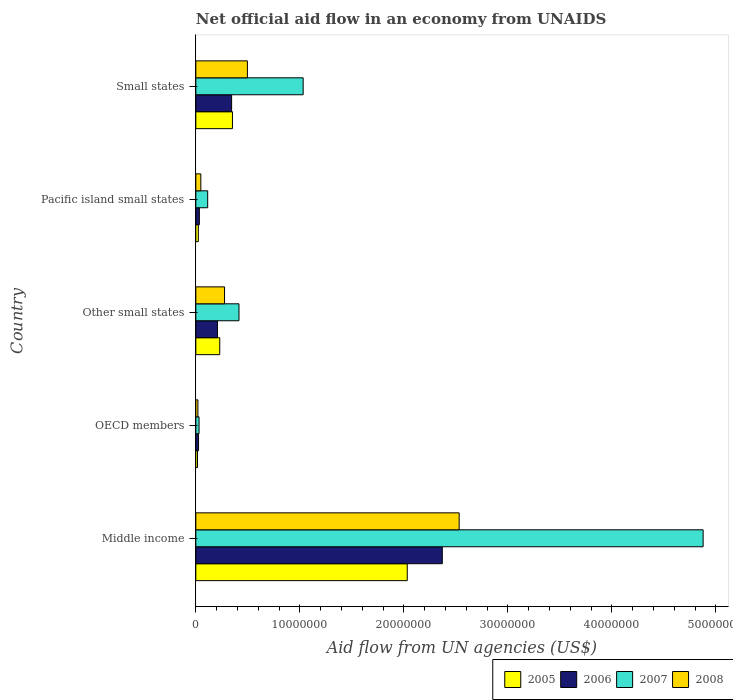How many groups of bars are there?
Ensure brevity in your answer.  5. Are the number of bars on each tick of the Y-axis equal?
Keep it short and to the point. Yes. How many bars are there on the 3rd tick from the top?
Provide a succinct answer. 4. What is the label of the 5th group of bars from the top?
Make the answer very short. Middle income. What is the net official aid flow in 2008 in Other small states?
Your answer should be compact. 2.76e+06. Across all countries, what is the maximum net official aid flow in 2005?
Offer a terse response. 2.03e+07. Across all countries, what is the minimum net official aid flow in 2007?
Your response must be concise. 3.10e+05. In which country was the net official aid flow in 2006 maximum?
Make the answer very short. Middle income. In which country was the net official aid flow in 2007 minimum?
Provide a succinct answer. OECD members. What is the total net official aid flow in 2005 in the graph?
Keep it short and to the point. 2.66e+07. What is the difference between the net official aid flow in 2005 in Pacific island small states and that in Small states?
Your response must be concise. -3.28e+06. What is the difference between the net official aid flow in 2007 in Other small states and the net official aid flow in 2006 in Middle income?
Provide a succinct answer. -1.96e+07. What is the average net official aid flow in 2006 per country?
Provide a short and direct response. 5.96e+06. What is the difference between the net official aid flow in 2005 and net official aid flow in 2008 in Small states?
Provide a succinct answer. -1.44e+06. In how many countries, is the net official aid flow in 2007 greater than 12000000 US$?
Your answer should be compact. 1. What is the ratio of the net official aid flow in 2005 in Pacific island small states to that in Small states?
Provide a succinct answer. 0.07. Is the difference between the net official aid flow in 2005 in Middle income and Small states greater than the difference between the net official aid flow in 2008 in Middle income and Small states?
Make the answer very short. No. What is the difference between the highest and the second highest net official aid flow in 2008?
Keep it short and to the point. 2.04e+07. What is the difference between the highest and the lowest net official aid flow in 2006?
Your answer should be compact. 2.34e+07. In how many countries, is the net official aid flow in 2006 greater than the average net official aid flow in 2006 taken over all countries?
Your response must be concise. 1. Is it the case that in every country, the sum of the net official aid flow in 2007 and net official aid flow in 2008 is greater than the sum of net official aid flow in 2005 and net official aid flow in 2006?
Ensure brevity in your answer.  No. What does the 4th bar from the top in Pacific island small states represents?
Offer a terse response. 2005. Is it the case that in every country, the sum of the net official aid flow in 2005 and net official aid flow in 2006 is greater than the net official aid flow in 2007?
Give a very brief answer. No. How many bars are there?
Your answer should be compact. 20. How many countries are there in the graph?
Provide a short and direct response. 5. What is the difference between two consecutive major ticks on the X-axis?
Your answer should be compact. 1.00e+07. Does the graph contain any zero values?
Offer a terse response. No. Does the graph contain grids?
Ensure brevity in your answer.  No. Where does the legend appear in the graph?
Your answer should be compact. Bottom right. What is the title of the graph?
Keep it short and to the point. Net official aid flow in an economy from UNAIDS. Does "2002" appear as one of the legend labels in the graph?
Offer a very short reply. No. What is the label or title of the X-axis?
Provide a succinct answer. Aid flow from UN agencies (US$). What is the Aid flow from UN agencies (US$) in 2005 in Middle income?
Your answer should be very brief. 2.03e+07. What is the Aid flow from UN agencies (US$) in 2006 in Middle income?
Offer a very short reply. 2.37e+07. What is the Aid flow from UN agencies (US$) of 2007 in Middle income?
Offer a terse response. 4.88e+07. What is the Aid flow from UN agencies (US$) of 2008 in Middle income?
Make the answer very short. 2.53e+07. What is the Aid flow from UN agencies (US$) of 2005 in OECD members?
Keep it short and to the point. 1.60e+05. What is the Aid flow from UN agencies (US$) of 2007 in OECD members?
Your answer should be compact. 3.10e+05. What is the Aid flow from UN agencies (US$) in 2005 in Other small states?
Offer a terse response. 2.30e+06. What is the Aid flow from UN agencies (US$) of 2006 in Other small states?
Provide a short and direct response. 2.08e+06. What is the Aid flow from UN agencies (US$) in 2007 in Other small states?
Your response must be concise. 4.15e+06. What is the Aid flow from UN agencies (US$) in 2008 in Other small states?
Keep it short and to the point. 2.76e+06. What is the Aid flow from UN agencies (US$) in 2005 in Pacific island small states?
Your response must be concise. 2.40e+05. What is the Aid flow from UN agencies (US$) in 2006 in Pacific island small states?
Provide a succinct answer. 3.40e+05. What is the Aid flow from UN agencies (US$) in 2007 in Pacific island small states?
Ensure brevity in your answer.  1.14e+06. What is the Aid flow from UN agencies (US$) of 2005 in Small states?
Make the answer very short. 3.52e+06. What is the Aid flow from UN agencies (US$) of 2006 in Small states?
Offer a terse response. 3.44e+06. What is the Aid flow from UN agencies (US$) in 2007 in Small states?
Provide a succinct answer. 1.03e+07. What is the Aid flow from UN agencies (US$) of 2008 in Small states?
Ensure brevity in your answer.  4.96e+06. Across all countries, what is the maximum Aid flow from UN agencies (US$) of 2005?
Keep it short and to the point. 2.03e+07. Across all countries, what is the maximum Aid flow from UN agencies (US$) in 2006?
Keep it short and to the point. 2.37e+07. Across all countries, what is the maximum Aid flow from UN agencies (US$) in 2007?
Provide a succinct answer. 4.88e+07. Across all countries, what is the maximum Aid flow from UN agencies (US$) in 2008?
Offer a terse response. 2.53e+07. Across all countries, what is the minimum Aid flow from UN agencies (US$) in 2006?
Ensure brevity in your answer.  2.60e+05. Across all countries, what is the minimum Aid flow from UN agencies (US$) of 2008?
Your answer should be compact. 2.00e+05. What is the total Aid flow from UN agencies (US$) in 2005 in the graph?
Your answer should be very brief. 2.66e+07. What is the total Aid flow from UN agencies (US$) in 2006 in the graph?
Keep it short and to the point. 2.98e+07. What is the total Aid flow from UN agencies (US$) of 2007 in the graph?
Give a very brief answer. 6.47e+07. What is the total Aid flow from UN agencies (US$) in 2008 in the graph?
Your answer should be very brief. 3.37e+07. What is the difference between the Aid flow from UN agencies (US$) in 2005 in Middle income and that in OECD members?
Offer a terse response. 2.02e+07. What is the difference between the Aid flow from UN agencies (US$) in 2006 in Middle income and that in OECD members?
Your response must be concise. 2.34e+07. What is the difference between the Aid flow from UN agencies (US$) in 2007 in Middle income and that in OECD members?
Offer a terse response. 4.85e+07. What is the difference between the Aid flow from UN agencies (US$) of 2008 in Middle income and that in OECD members?
Your response must be concise. 2.51e+07. What is the difference between the Aid flow from UN agencies (US$) in 2005 in Middle income and that in Other small states?
Keep it short and to the point. 1.80e+07. What is the difference between the Aid flow from UN agencies (US$) in 2006 in Middle income and that in Other small states?
Keep it short and to the point. 2.16e+07. What is the difference between the Aid flow from UN agencies (US$) in 2007 in Middle income and that in Other small states?
Your response must be concise. 4.46e+07. What is the difference between the Aid flow from UN agencies (US$) of 2008 in Middle income and that in Other small states?
Keep it short and to the point. 2.26e+07. What is the difference between the Aid flow from UN agencies (US$) of 2005 in Middle income and that in Pacific island small states?
Keep it short and to the point. 2.01e+07. What is the difference between the Aid flow from UN agencies (US$) of 2006 in Middle income and that in Pacific island small states?
Ensure brevity in your answer.  2.34e+07. What is the difference between the Aid flow from UN agencies (US$) of 2007 in Middle income and that in Pacific island small states?
Offer a terse response. 4.76e+07. What is the difference between the Aid flow from UN agencies (US$) in 2008 in Middle income and that in Pacific island small states?
Give a very brief answer. 2.48e+07. What is the difference between the Aid flow from UN agencies (US$) in 2005 in Middle income and that in Small states?
Make the answer very short. 1.68e+07. What is the difference between the Aid flow from UN agencies (US$) in 2006 in Middle income and that in Small states?
Make the answer very short. 2.03e+07. What is the difference between the Aid flow from UN agencies (US$) of 2007 in Middle income and that in Small states?
Your answer should be compact. 3.85e+07. What is the difference between the Aid flow from UN agencies (US$) in 2008 in Middle income and that in Small states?
Offer a terse response. 2.04e+07. What is the difference between the Aid flow from UN agencies (US$) of 2005 in OECD members and that in Other small states?
Offer a very short reply. -2.14e+06. What is the difference between the Aid flow from UN agencies (US$) in 2006 in OECD members and that in Other small states?
Provide a short and direct response. -1.82e+06. What is the difference between the Aid flow from UN agencies (US$) in 2007 in OECD members and that in Other small states?
Provide a succinct answer. -3.84e+06. What is the difference between the Aid flow from UN agencies (US$) in 2008 in OECD members and that in Other small states?
Make the answer very short. -2.56e+06. What is the difference between the Aid flow from UN agencies (US$) in 2007 in OECD members and that in Pacific island small states?
Make the answer very short. -8.30e+05. What is the difference between the Aid flow from UN agencies (US$) in 2008 in OECD members and that in Pacific island small states?
Provide a short and direct response. -2.80e+05. What is the difference between the Aid flow from UN agencies (US$) in 2005 in OECD members and that in Small states?
Your answer should be very brief. -3.36e+06. What is the difference between the Aid flow from UN agencies (US$) of 2006 in OECD members and that in Small states?
Keep it short and to the point. -3.18e+06. What is the difference between the Aid flow from UN agencies (US$) of 2007 in OECD members and that in Small states?
Offer a terse response. -1.00e+07. What is the difference between the Aid flow from UN agencies (US$) in 2008 in OECD members and that in Small states?
Provide a succinct answer. -4.76e+06. What is the difference between the Aid flow from UN agencies (US$) in 2005 in Other small states and that in Pacific island small states?
Keep it short and to the point. 2.06e+06. What is the difference between the Aid flow from UN agencies (US$) in 2006 in Other small states and that in Pacific island small states?
Your answer should be very brief. 1.74e+06. What is the difference between the Aid flow from UN agencies (US$) in 2007 in Other small states and that in Pacific island small states?
Provide a short and direct response. 3.01e+06. What is the difference between the Aid flow from UN agencies (US$) of 2008 in Other small states and that in Pacific island small states?
Make the answer very short. 2.28e+06. What is the difference between the Aid flow from UN agencies (US$) of 2005 in Other small states and that in Small states?
Give a very brief answer. -1.22e+06. What is the difference between the Aid flow from UN agencies (US$) of 2006 in Other small states and that in Small states?
Your answer should be very brief. -1.36e+06. What is the difference between the Aid flow from UN agencies (US$) of 2007 in Other small states and that in Small states?
Your answer should be very brief. -6.17e+06. What is the difference between the Aid flow from UN agencies (US$) of 2008 in Other small states and that in Small states?
Keep it short and to the point. -2.20e+06. What is the difference between the Aid flow from UN agencies (US$) of 2005 in Pacific island small states and that in Small states?
Provide a short and direct response. -3.28e+06. What is the difference between the Aid flow from UN agencies (US$) of 2006 in Pacific island small states and that in Small states?
Offer a terse response. -3.10e+06. What is the difference between the Aid flow from UN agencies (US$) in 2007 in Pacific island small states and that in Small states?
Provide a succinct answer. -9.18e+06. What is the difference between the Aid flow from UN agencies (US$) of 2008 in Pacific island small states and that in Small states?
Offer a terse response. -4.48e+06. What is the difference between the Aid flow from UN agencies (US$) in 2005 in Middle income and the Aid flow from UN agencies (US$) in 2006 in OECD members?
Provide a short and direct response. 2.01e+07. What is the difference between the Aid flow from UN agencies (US$) in 2005 in Middle income and the Aid flow from UN agencies (US$) in 2007 in OECD members?
Provide a short and direct response. 2.00e+07. What is the difference between the Aid flow from UN agencies (US$) in 2005 in Middle income and the Aid flow from UN agencies (US$) in 2008 in OECD members?
Provide a short and direct response. 2.01e+07. What is the difference between the Aid flow from UN agencies (US$) in 2006 in Middle income and the Aid flow from UN agencies (US$) in 2007 in OECD members?
Provide a short and direct response. 2.34e+07. What is the difference between the Aid flow from UN agencies (US$) of 2006 in Middle income and the Aid flow from UN agencies (US$) of 2008 in OECD members?
Your response must be concise. 2.35e+07. What is the difference between the Aid flow from UN agencies (US$) in 2007 in Middle income and the Aid flow from UN agencies (US$) in 2008 in OECD members?
Keep it short and to the point. 4.86e+07. What is the difference between the Aid flow from UN agencies (US$) in 2005 in Middle income and the Aid flow from UN agencies (US$) in 2006 in Other small states?
Provide a short and direct response. 1.82e+07. What is the difference between the Aid flow from UN agencies (US$) of 2005 in Middle income and the Aid flow from UN agencies (US$) of 2007 in Other small states?
Ensure brevity in your answer.  1.62e+07. What is the difference between the Aid flow from UN agencies (US$) in 2005 in Middle income and the Aid flow from UN agencies (US$) in 2008 in Other small states?
Keep it short and to the point. 1.76e+07. What is the difference between the Aid flow from UN agencies (US$) of 2006 in Middle income and the Aid flow from UN agencies (US$) of 2007 in Other small states?
Make the answer very short. 1.96e+07. What is the difference between the Aid flow from UN agencies (US$) in 2006 in Middle income and the Aid flow from UN agencies (US$) in 2008 in Other small states?
Your answer should be very brief. 2.09e+07. What is the difference between the Aid flow from UN agencies (US$) in 2007 in Middle income and the Aid flow from UN agencies (US$) in 2008 in Other small states?
Your response must be concise. 4.60e+07. What is the difference between the Aid flow from UN agencies (US$) of 2005 in Middle income and the Aid flow from UN agencies (US$) of 2006 in Pacific island small states?
Offer a terse response. 2.00e+07. What is the difference between the Aid flow from UN agencies (US$) of 2005 in Middle income and the Aid flow from UN agencies (US$) of 2007 in Pacific island small states?
Offer a very short reply. 1.92e+07. What is the difference between the Aid flow from UN agencies (US$) of 2005 in Middle income and the Aid flow from UN agencies (US$) of 2008 in Pacific island small states?
Ensure brevity in your answer.  1.98e+07. What is the difference between the Aid flow from UN agencies (US$) of 2006 in Middle income and the Aid flow from UN agencies (US$) of 2007 in Pacific island small states?
Give a very brief answer. 2.26e+07. What is the difference between the Aid flow from UN agencies (US$) in 2006 in Middle income and the Aid flow from UN agencies (US$) in 2008 in Pacific island small states?
Offer a terse response. 2.32e+07. What is the difference between the Aid flow from UN agencies (US$) of 2007 in Middle income and the Aid flow from UN agencies (US$) of 2008 in Pacific island small states?
Make the answer very short. 4.83e+07. What is the difference between the Aid flow from UN agencies (US$) in 2005 in Middle income and the Aid flow from UN agencies (US$) in 2006 in Small states?
Provide a succinct answer. 1.69e+07. What is the difference between the Aid flow from UN agencies (US$) in 2005 in Middle income and the Aid flow from UN agencies (US$) in 2007 in Small states?
Make the answer very short. 1.00e+07. What is the difference between the Aid flow from UN agencies (US$) in 2005 in Middle income and the Aid flow from UN agencies (US$) in 2008 in Small states?
Your response must be concise. 1.54e+07. What is the difference between the Aid flow from UN agencies (US$) in 2006 in Middle income and the Aid flow from UN agencies (US$) in 2007 in Small states?
Your answer should be compact. 1.34e+07. What is the difference between the Aid flow from UN agencies (US$) in 2006 in Middle income and the Aid flow from UN agencies (US$) in 2008 in Small states?
Provide a short and direct response. 1.87e+07. What is the difference between the Aid flow from UN agencies (US$) of 2007 in Middle income and the Aid flow from UN agencies (US$) of 2008 in Small states?
Provide a succinct answer. 4.38e+07. What is the difference between the Aid flow from UN agencies (US$) of 2005 in OECD members and the Aid flow from UN agencies (US$) of 2006 in Other small states?
Make the answer very short. -1.92e+06. What is the difference between the Aid flow from UN agencies (US$) of 2005 in OECD members and the Aid flow from UN agencies (US$) of 2007 in Other small states?
Ensure brevity in your answer.  -3.99e+06. What is the difference between the Aid flow from UN agencies (US$) in 2005 in OECD members and the Aid flow from UN agencies (US$) in 2008 in Other small states?
Give a very brief answer. -2.60e+06. What is the difference between the Aid flow from UN agencies (US$) in 2006 in OECD members and the Aid flow from UN agencies (US$) in 2007 in Other small states?
Offer a terse response. -3.89e+06. What is the difference between the Aid flow from UN agencies (US$) in 2006 in OECD members and the Aid flow from UN agencies (US$) in 2008 in Other small states?
Your answer should be compact. -2.50e+06. What is the difference between the Aid flow from UN agencies (US$) of 2007 in OECD members and the Aid flow from UN agencies (US$) of 2008 in Other small states?
Keep it short and to the point. -2.45e+06. What is the difference between the Aid flow from UN agencies (US$) of 2005 in OECD members and the Aid flow from UN agencies (US$) of 2007 in Pacific island small states?
Offer a very short reply. -9.80e+05. What is the difference between the Aid flow from UN agencies (US$) of 2005 in OECD members and the Aid flow from UN agencies (US$) of 2008 in Pacific island small states?
Offer a very short reply. -3.20e+05. What is the difference between the Aid flow from UN agencies (US$) in 2006 in OECD members and the Aid flow from UN agencies (US$) in 2007 in Pacific island small states?
Provide a short and direct response. -8.80e+05. What is the difference between the Aid flow from UN agencies (US$) in 2007 in OECD members and the Aid flow from UN agencies (US$) in 2008 in Pacific island small states?
Your response must be concise. -1.70e+05. What is the difference between the Aid flow from UN agencies (US$) of 2005 in OECD members and the Aid flow from UN agencies (US$) of 2006 in Small states?
Offer a terse response. -3.28e+06. What is the difference between the Aid flow from UN agencies (US$) in 2005 in OECD members and the Aid flow from UN agencies (US$) in 2007 in Small states?
Keep it short and to the point. -1.02e+07. What is the difference between the Aid flow from UN agencies (US$) of 2005 in OECD members and the Aid flow from UN agencies (US$) of 2008 in Small states?
Your answer should be very brief. -4.80e+06. What is the difference between the Aid flow from UN agencies (US$) of 2006 in OECD members and the Aid flow from UN agencies (US$) of 2007 in Small states?
Your response must be concise. -1.01e+07. What is the difference between the Aid flow from UN agencies (US$) in 2006 in OECD members and the Aid flow from UN agencies (US$) in 2008 in Small states?
Your response must be concise. -4.70e+06. What is the difference between the Aid flow from UN agencies (US$) of 2007 in OECD members and the Aid flow from UN agencies (US$) of 2008 in Small states?
Offer a terse response. -4.65e+06. What is the difference between the Aid flow from UN agencies (US$) of 2005 in Other small states and the Aid flow from UN agencies (US$) of 2006 in Pacific island small states?
Provide a short and direct response. 1.96e+06. What is the difference between the Aid flow from UN agencies (US$) in 2005 in Other small states and the Aid flow from UN agencies (US$) in 2007 in Pacific island small states?
Your response must be concise. 1.16e+06. What is the difference between the Aid flow from UN agencies (US$) of 2005 in Other small states and the Aid flow from UN agencies (US$) of 2008 in Pacific island small states?
Offer a terse response. 1.82e+06. What is the difference between the Aid flow from UN agencies (US$) of 2006 in Other small states and the Aid flow from UN agencies (US$) of 2007 in Pacific island small states?
Your answer should be very brief. 9.40e+05. What is the difference between the Aid flow from UN agencies (US$) in 2006 in Other small states and the Aid flow from UN agencies (US$) in 2008 in Pacific island small states?
Give a very brief answer. 1.60e+06. What is the difference between the Aid flow from UN agencies (US$) in 2007 in Other small states and the Aid flow from UN agencies (US$) in 2008 in Pacific island small states?
Give a very brief answer. 3.67e+06. What is the difference between the Aid flow from UN agencies (US$) in 2005 in Other small states and the Aid flow from UN agencies (US$) in 2006 in Small states?
Make the answer very short. -1.14e+06. What is the difference between the Aid flow from UN agencies (US$) in 2005 in Other small states and the Aid flow from UN agencies (US$) in 2007 in Small states?
Provide a short and direct response. -8.02e+06. What is the difference between the Aid flow from UN agencies (US$) of 2005 in Other small states and the Aid flow from UN agencies (US$) of 2008 in Small states?
Ensure brevity in your answer.  -2.66e+06. What is the difference between the Aid flow from UN agencies (US$) of 2006 in Other small states and the Aid flow from UN agencies (US$) of 2007 in Small states?
Your response must be concise. -8.24e+06. What is the difference between the Aid flow from UN agencies (US$) in 2006 in Other small states and the Aid flow from UN agencies (US$) in 2008 in Small states?
Give a very brief answer. -2.88e+06. What is the difference between the Aid flow from UN agencies (US$) of 2007 in Other small states and the Aid flow from UN agencies (US$) of 2008 in Small states?
Keep it short and to the point. -8.10e+05. What is the difference between the Aid flow from UN agencies (US$) in 2005 in Pacific island small states and the Aid flow from UN agencies (US$) in 2006 in Small states?
Your response must be concise. -3.20e+06. What is the difference between the Aid flow from UN agencies (US$) in 2005 in Pacific island small states and the Aid flow from UN agencies (US$) in 2007 in Small states?
Provide a succinct answer. -1.01e+07. What is the difference between the Aid flow from UN agencies (US$) in 2005 in Pacific island small states and the Aid flow from UN agencies (US$) in 2008 in Small states?
Offer a very short reply. -4.72e+06. What is the difference between the Aid flow from UN agencies (US$) of 2006 in Pacific island small states and the Aid flow from UN agencies (US$) of 2007 in Small states?
Provide a succinct answer. -9.98e+06. What is the difference between the Aid flow from UN agencies (US$) in 2006 in Pacific island small states and the Aid flow from UN agencies (US$) in 2008 in Small states?
Provide a short and direct response. -4.62e+06. What is the difference between the Aid flow from UN agencies (US$) of 2007 in Pacific island small states and the Aid flow from UN agencies (US$) of 2008 in Small states?
Offer a terse response. -3.82e+06. What is the average Aid flow from UN agencies (US$) in 2005 per country?
Your answer should be compact. 5.31e+06. What is the average Aid flow from UN agencies (US$) of 2006 per country?
Give a very brief answer. 5.96e+06. What is the average Aid flow from UN agencies (US$) in 2007 per country?
Your response must be concise. 1.29e+07. What is the average Aid flow from UN agencies (US$) in 2008 per country?
Provide a short and direct response. 6.74e+06. What is the difference between the Aid flow from UN agencies (US$) in 2005 and Aid flow from UN agencies (US$) in 2006 in Middle income?
Your answer should be compact. -3.37e+06. What is the difference between the Aid flow from UN agencies (US$) of 2005 and Aid flow from UN agencies (US$) of 2007 in Middle income?
Offer a very short reply. -2.84e+07. What is the difference between the Aid flow from UN agencies (US$) of 2005 and Aid flow from UN agencies (US$) of 2008 in Middle income?
Provide a succinct answer. -4.99e+06. What is the difference between the Aid flow from UN agencies (US$) of 2006 and Aid flow from UN agencies (US$) of 2007 in Middle income?
Provide a short and direct response. -2.51e+07. What is the difference between the Aid flow from UN agencies (US$) of 2006 and Aid flow from UN agencies (US$) of 2008 in Middle income?
Ensure brevity in your answer.  -1.62e+06. What is the difference between the Aid flow from UN agencies (US$) of 2007 and Aid flow from UN agencies (US$) of 2008 in Middle income?
Ensure brevity in your answer.  2.35e+07. What is the difference between the Aid flow from UN agencies (US$) of 2005 and Aid flow from UN agencies (US$) of 2008 in OECD members?
Give a very brief answer. -4.00e+04. What is the difference between the Aid flow from UN agencies (US$) of 2007 and Aid flow from UN agencies (US$) of 2008 in OECD members?
Offer a very short reply. 1.10e+05. What is the difference between the Aid flow from UN agencies (US$) in 2005 and Aid flow from UN agencies (US$) in 2007 in Other small states?
Ensure brevity in your answer.  -1.85e+06. What is the difference between the Aid flow from UN agencies (US$) of 2005 and Aid flow from UN agencies (US$) of 2008 in Other small states?
Make the answer very short. -4.60e+05. What is the difference between the Aid flow from UN agencies (US$) of 2006 and Aid flow from UN agencies (US$) of 2007 in Other small states?
Your answer should be very brief. -2.07e+06. What is the difference between the Aid flow from UN agencies (US$) of 2006 and Aid flow from UN agencies (US$) of 2008 in Other small states?
Make the answer very short. -6.80e+05. What is the difference between the Aid flow from UN agencies (US$) in 2007 and Aid flow from UN agencies (US$) in 2008 in Other small states?
Your response must be concise. 1.39e+06. What is the difference between the Aid flow from UN agencies (US$) of 2005 and Aid flow from UN agencies (US$) of 2006 in Pacific island small states?
Ensure brevity in your answer.  -1.00e+05. What is the difference between the Aid flow from UN agencies (US$) of 2005 and Aid flow from UN agencies (US$) of 2007 in Pacific island small states?
Your response must be concise. -9.00e+05. What is the difference between the Aid flow from UN agencies (US$) in 2005 and Aid flow from UN agencies (US$) in 2008 in Pacific island small states?
Your response must be concise. -2.40e+05. What is the difference between the Aid flow from UN agencies (US$) in 2006 and Aid flow from UN agencies (US$) in 2007 in Pacific island small states?
Your response must be concise. -8.00e+05. What is the difference between the Aid flow from UN agencies (US$) in 2006 and Aid flow from UN agencies (US$) in 2008 in Pacific island small states?
Your response must be concise. -1.40e+05. What is the difference between the Aid flow from UN agencies (US$) of 2005 and Aid flow from UN agencies (US$) of 2006 in Small states?
Your answer should be compact. 8.00e+04. What is the difference between the Aid flow from UN agencies (US$) in 2005 and Aid flow from UN agencies (US$) in 2007 in Small states?
Offer a terse response. -6.80e+06. What is the difference between the Aid flow from UN agencies (US$) of 2005 and Aid flow from UN agencies (US$) of 2008 in Small states?
Offer a very short reply. -1.44e+06. What is the difference between the Aid flow from UN agencies (US$) in 2006 and Aid flow from UN agencies (US$) in 2007 in Small states?
Give a very brief answer. -6.88e+06. What is the difference between the Aid flow from UN agencies (US$) in 2006 and Aid flow from UN agencies (US$) in 2008 in Small states?
Keep it short and to the point. -1.52e+06. What is the difference between the Aid flow from UN agencies (US$) of 2007 and Aid flow from UN agencies (US$) of 2008 in Small states?
Your answer should be very brief. 5.36e+06. What is the ratio of the Aid flow from UN agencies (US$) in 2005 in Middle income to that in OECD members?
Your response must be concise. 127.06. What is the ratio of the Aid flow from UN agencies (US$) of 2006 in Middle income to that in OECD members?
Offer a terse response. 91.15. What is the ratio of the Aid flow from UN agencies (US$) in 2007 in Middle income to that in OECD members?
Ensure brevity in your answer.  157.35. What is the ratio of the Aid flow from UN agencies (US$) of 2008 in Middle income to that in OECD members?
Give a very brief answer. 126.6. What is the ratio of the Aid flow from UN agencies (US$) in 2005 in Middle income to that in Other small states?
Provide a short and direct response. 8.84. What is the ratio of the Aid flow from UN agencies (US$) in 2006 in Middle income to that in Other small states?
Your answer should be very brief. 11.39. What is the ratio of the Aid flow from UN agencies (US$) of 2007 in Middle income to that in Other small states?
Your response must be concise. 11.75. What is the ratio of the Aid flow from UN agencies (US$) of 2008 in Middle income to that in Other small states?
Provide a succinct answer. 9.17. What is the ratio of the Aid flow from UN agencies (US$) in 2005 in Middle income to that in Pacific island small states?
Your response must be concise. 84.71. What is the ratio of the Aid flow from UN agencies (US$) in 2006 in Middle income to that in Pacific island small states?
Your answer should be compact. 69.71. What is the ratio of the Aid flow from UN agencies (US$) of 2007 in Middle income to that in Pacific island small states?
Your response must be concise. 42.79. What is the ratio of the Aid flow from UN agencies (US$) in 2008 in Middle income to that in Pacific island small states?
Provide a succinct answer. 52.75. What is the ratio of the Aid flow from UN agencies (US$) in 2005 in Middle income to that in Small states?
Provide a short and direct response. 5.78. What is the ratio of the Aid flow from UN agencies (US$) in 2006 in Middle income to that in Small states?
Provide a short and direct response. 6.89. What is the ratio of the Aid flow from UN agencies (US$) of 2007 in Middle income to that in Small states?
Your response must be concise. 4.73. What is the ratio of the Aid flow from UN agencies (US$) in 2008 in Middle income to that in Small states?
Your answer should be very brief. 5.1. What is the ratio of the Aid flow from UN agencies (US$) in 2005 in OECD members to that in Other small states?
Provide a short and direct response. 0.07. What is the ratio of the Aid flow from UN agencies (US$) in 2006 in OECD members to that in Other small states?
Your answer should be very brief. 0.12. What is the ratio of the Aid flow from UN agencies (US$) in 2007 in OECD members to that in Other small states?
Offer a terse response. 0.07. What is the ratio of the Aid flow from UN agencies (US$) of 2008 in OECD members to that in Other small states?
Ensure brevity in your answer.  0.07. What is the ratio of the Aid flow from UN agencies (US$) of 2005 in OECD members to that in Pacific island small states?
Offer a terse response. 0.67. What is the ratio of the Aid flow from UN agencies (US$) of 2006 in OECD members to that in Pacific island small states?
Your answer should be very brief. 0.76. What is the ratio of the Aid flow from UN agencies (US$) in 2007 in OECD members to that in Pacific island small states?
Offer a very short reply. 0.27. What is the ratio of the Aid flow from UN agencies (US$) of 2008 in OECD members to that in Pacific island small states?
Provide a short and direct response. 0.42. What is the ratio of the Aid flow from UN agencies (US$) in 2005 in OECD members to that in Small states?
Your answer should be compact. 0.05. What is the ratio of the Aid flow from UN agencies (US$) in 2006 in OECD members to that in Small states?
Your answer should be compact. 0.08. What is the ratio of the Aid flow from UN agencies (US$) of 2008 in OECD members to that in Small states?
Ensure brevity in your answer.  0.04. What is the ratio of the Aid flow from UN agencies (US$) in 2005 in Other small states to that in Pacific island small states?
Your answer should be very brief. 9.58. What is the ratio of the Aid flow from UN agencies (US$) in 2006 in Other small states to that in Pacific island small states?
Provide a short and direct response. 6.12. What is the ratio of the Aid flow from UN agencies (US$) of 2007 in Other small states to that in Pacific island small states?
Your answer should be compact. 3.64. What is the ratio of the Aid flow from UN agencies (US$) of 2008 in Other small states to that in Pacific island small states?
Your answer should be compact. 5.75. What is the ratio of the Aid flow from UN agencies (US$) in 2005 in Other small states to that in Small states?
Your response must be concise. 0.65. What is the ratio of the Aid flow from UN agencies (US$) in 2006 in Other small states to that in Small states?
Your answer should be very brief. 0.6. What is the ratio of the Aid flow from UN agencies (US$) in 2007 in Other small states to that in Small states?
Provide a succinct answer. 0.4. What is the ratio of the Aid flow from UN agencies (US$) in 2008 in Other small states to that in Small states?
Give a very brief answer. 0.56. What is the ratio of the Aid flow from UN agencies (US$) of 2005 in Pacific island small states to that in Small states?
Provide a short and direct response. 0.07. What is the ratio of the Aid flow from UN agencies (US$) of 2006 in Pacific island small states to that in Small states?
Make the answer very short. 0.1. What is the ratio of the Aid flow from UN agencies (US$) of 2007 in Pacific island small states to that in Small states?
Keep it short and to the point. 0.11. What is the ratio of the Aid flow from UN agencies (US$) in 2008 in Pacific island small states to that in Small states?
Your answer should be compact. 0.1. What is the difference between the highest and the second highest Aid flow from UN agencies (US$) in 2005?
Offer a very short reply. 1.68e+07. What is the difference between the highest and the second highest Aid flow from UN agencies (US$) of 2006?
Keep it short and to the point. 2.03e+07. What is the difference between the highest and the second highest Aid flow from UN agencies (US$) of 2007?
Your answer should be very brief. 3.85e+07. What is the difference between the highest and the second highest Aid flow from UN agencies (US$) of 2008?
Give a very brief answer. 2.04e+07. What is the difference between the highest and the lowest Aid flow from UN agencies (US$) in 2005?
Your answer should be compact. 2.02e+07. What is the difference between the highest and the lowest Aid flow from UN agencies (US$) in 2006?
Keep it short and to the point. 2.34e+07. What is the difference between the highest and the lowest Aid flow from UN agencies (US$) of 2007?
Your answer should be compact. 4.85e+07. What is the difference between the highest and the lowest Aid flow from UN agencies (US$) of 2008?
Provide a short and direct response. 2.51e+07. 